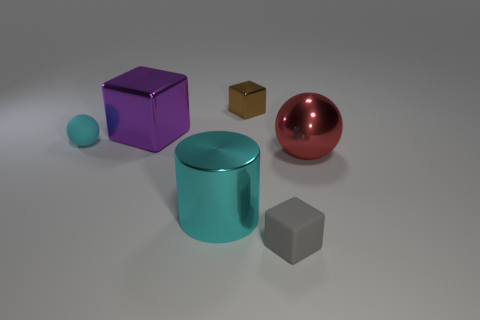How many metallic things are the same color as the big cube?
Make the answer very short. 0. Is there anything else that is the same shape as the gray rubber thing?
Provide a succinct answer. Yes. What number of balls are either tiny blue things or small brown shiny objects?
Your answer should be compact. 0. There is a ball that is right of the large purple object; what is its color?
Keep it short and to the point. Red. The purple metal thing that is the same size as the cylinder is what shape?
Provide a short and direct response. Cube. There is a cyan shiny cylinder; how many gray rubber cubes are in front of it?
Make the answer very short. 1. How many things are small brown shiny cubes or big red matte blocks?
Offer a terse response. 1. What is the shape of the small object that is right of the cyan ball and behind the big cyan cylinder?
Provide a short and direct response. Cube. How many small gray cubes are there?
Your response must be concise. 1. There is a ball that is made of the same material as the large purple object; what color is it?
Offer a terse response. Red. 